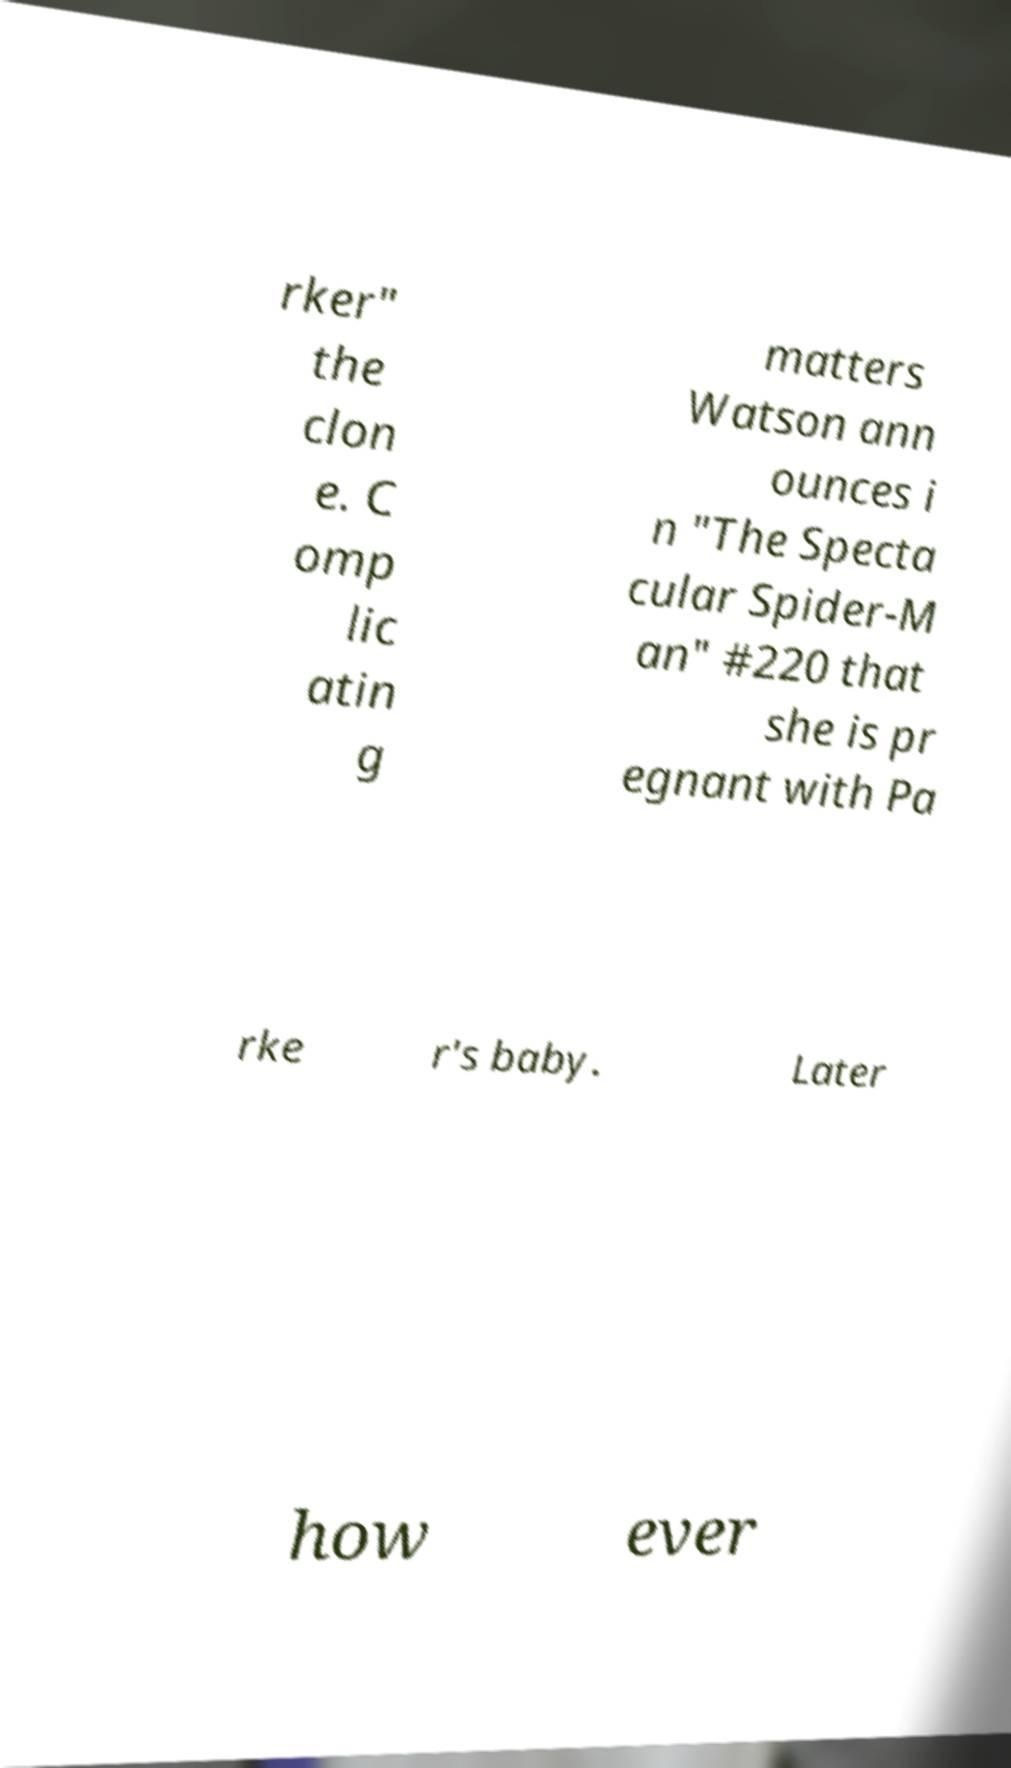Please identify and transcribe the text found in this image. rker" the clon e. C omp lic atin g matters Watson ann ounces i n "The Specta cular Spider-M an" #220 that she is pr egnant with Pa rke r's baby. Later how ever 